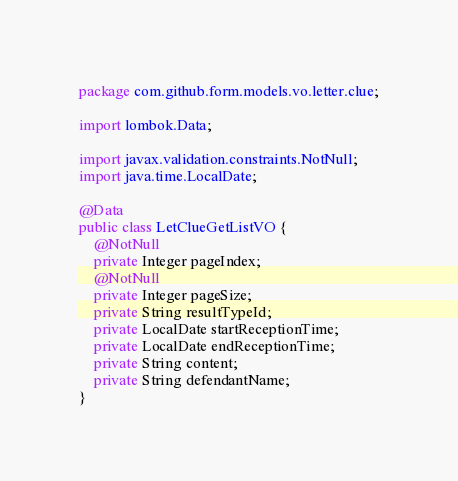<code> <loc_0><loc_0><loc_500><loc_500><_Java_>package com.github.form.models.vo.letter.clue;

import lombok.Data;

import javax.validation.constraints.NotNull;
import java.time.LocalDate;

@Data
public class LetClueGetListVO {
    @NotNull
    private Integer pageIndex;
    @NotNull
    private Integer pageSize;
    private String resultTypeId;
    private LocalDate startReceptionTime;
    private LocalDate endReceptionTime;
    private String content;
    private String defendantName;
}</code> 